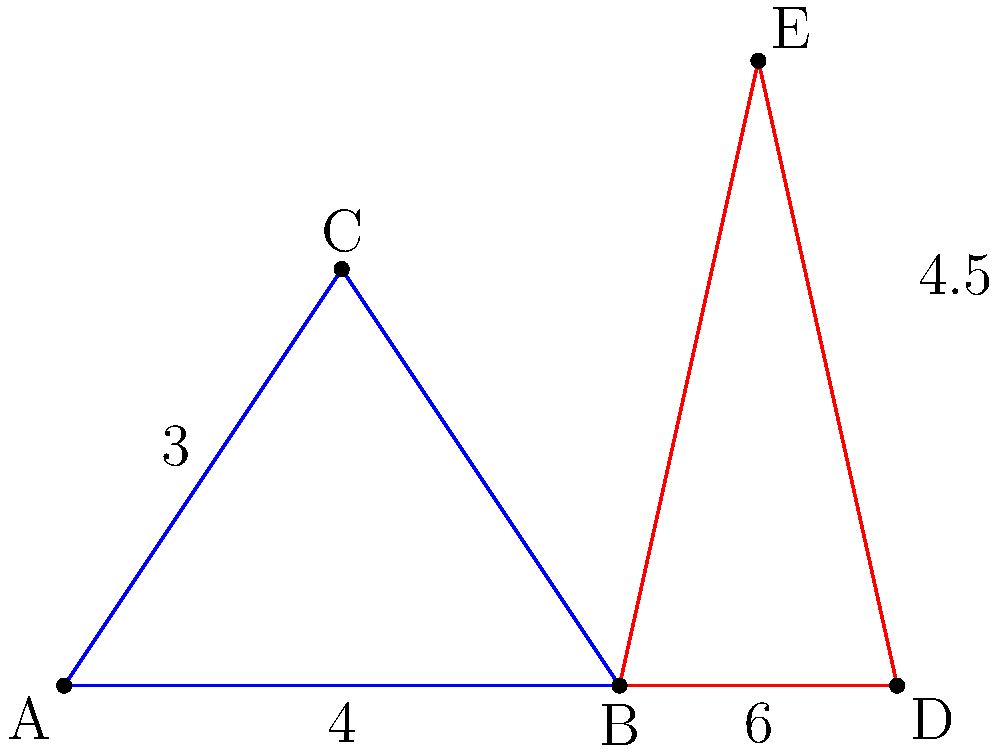In the diagram, triangle ABC is similar to triangle BDE. If the area of triangle ABC is 6 square units, what is the area of triangle BDE? Express your answer in terms of a scaling factor. To solve this problem, let's follow these steps:

1) First, we need to determine the scaling factor between the two triangles. We can do this by comparing corresponding sides.

2) In triangle ABC, the base (AB) is 4 units. In triangle BDE, the corresponding base (BD) is 6 units.

3) The scaling factor (k) is thus:

   $$k = \frac{BD}{AB} = \frac{6}{4} = 1.5$$

4) Now, we recall that when two similar figures have a linear scaling factor of k, their areas have a scaling factor of $k^2$.

5) Therefore, the area of triangle BDE ($A_{BDE}$) in relation to the area of triangle ABC ($A_{ABC}$) is:

   $$A_{BDE} = A_{ABC} * k^2$$

6) We're given that $A_{ABC} = 6$ square units. So:

   $$A_{BDE} = 6 * (1.5)^2 = 6 * 2.25 = 13.5$$ square units

7) To express this in terms of the scaling factor, we can write:

   $$A_{BDE} = 6k^2 = 6(1.5)^2 = 13.5$$ square units
Answer: $6k^2$ square units, where $k = 1.5$ 